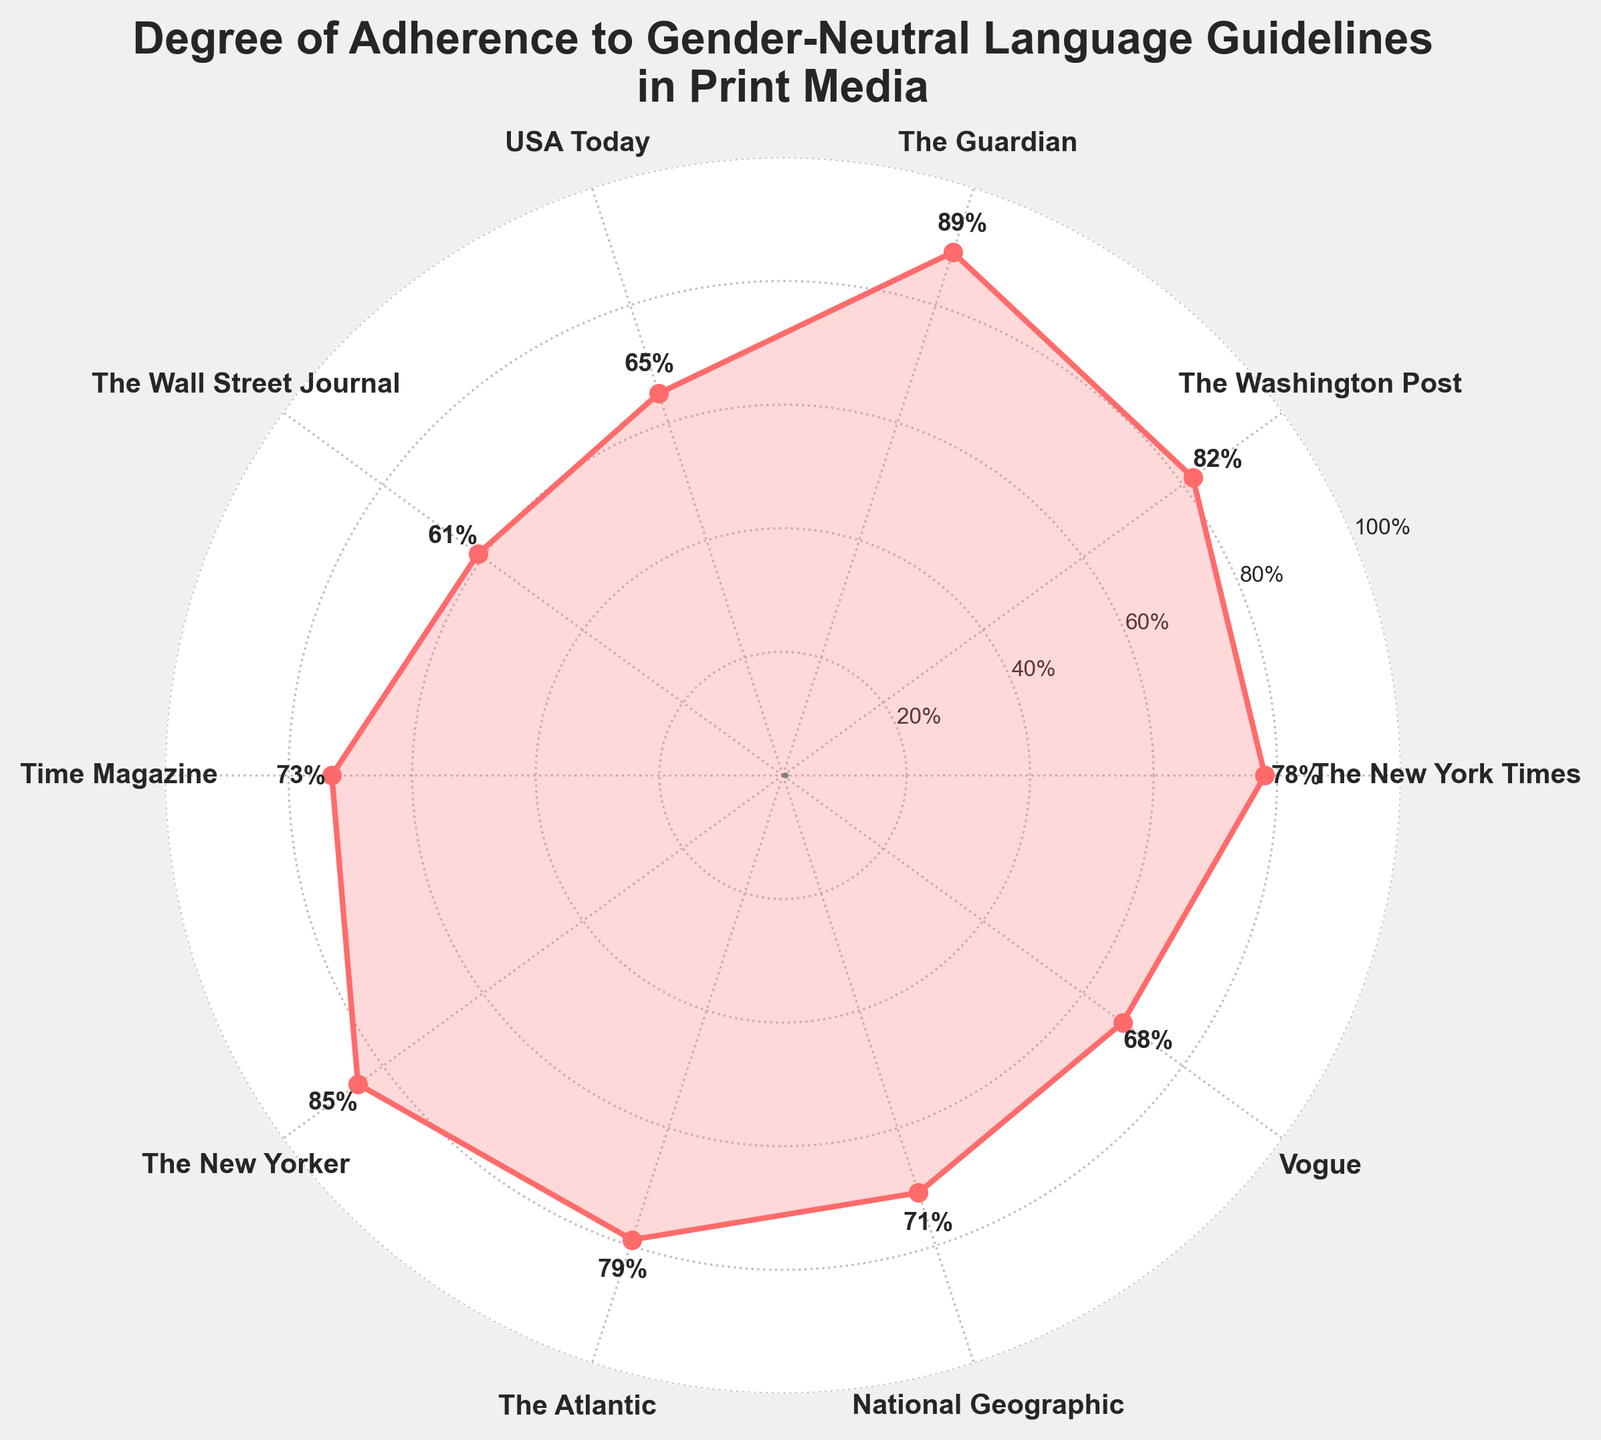What is the title of the chart? The title is located at the top of the chart. It reads, "Degree of Adherence to Gender-Neutral Language Guidelines in Print Media".
Answer: Degree of Adherence to Gender-Neutral Language Guidelines in Print Media Which publication has the lowest adherence percentage to gender-neutral language guidelines? By examining the points on the chart, The Wall Street Journal is associated with the lowest adherence percentage, positioned at 61% on the plot.
Answer: The Wall Street Journal What is the average adherence percentage across all publications? To find the average adherence percentage, sum all the percentage values and divide by the total number of publications: (78 + 82 + 89 + 65 + 61 + 73 + 85 + 79 + 71 + 68) / 10 = 75.1%
Answer: 75.1% Which publications have adherence percentages greater than 80%? From the chart, the publications with adherence percentages above 80% are The Washington Post (82%), The Guardian (89%), and The New Yorker (85%).
Answer: The Washington Post, The Guardian, The New Yorker What is the percentage difference between the publication with the highest adherence and the publication with the lowest adherence? The highest adherence percentage is The Guardian with 89%, and the lowest is The Wall Street Journal with 61%. The difference is 89% - 61% = 28%.
Answer: 28% How many publications have an adherence percentage below 70%? Counting the points on the chart below the 70% mark, we find The Wall Street Journal (61%), USA Today (65%), and Vogue (68%), resulting in three publications.
Answer: 3 What percentage is Time Magazine's adherence to gender-neutral language guidelines? Time Magazine's adherence percentage can be found directly on the chart, marked at 73%.
Answer: 73% Between National Geographic and Vogue, which publication has a higher adherence percentage, and by how much? National Geographic has an adherence percentage of 71%, while Vogue has 68%. The difference is 71% - 68% = 3%.
Answer: National Geographic, 3% What is the median adherence percentage of the publications? To find the median, sort the adherence percentages and identify the middle value. The sorted values are [61, 65, 68, 71, 73, 78, 79, 82, 85, 89]. The median is the average of the 5th and 6th values: (73 + 78) / 2 = 75.5%.
Answer: 75.5% Which three publications are closest in adherence percentage, and what are these percentages? By analyzing the data points, we find that The New York Times (78%), The Atlantic (79%), and National Geographic (71%) are closest to each other.
Answer: The New York Times, The Atlantic, National Geographic 